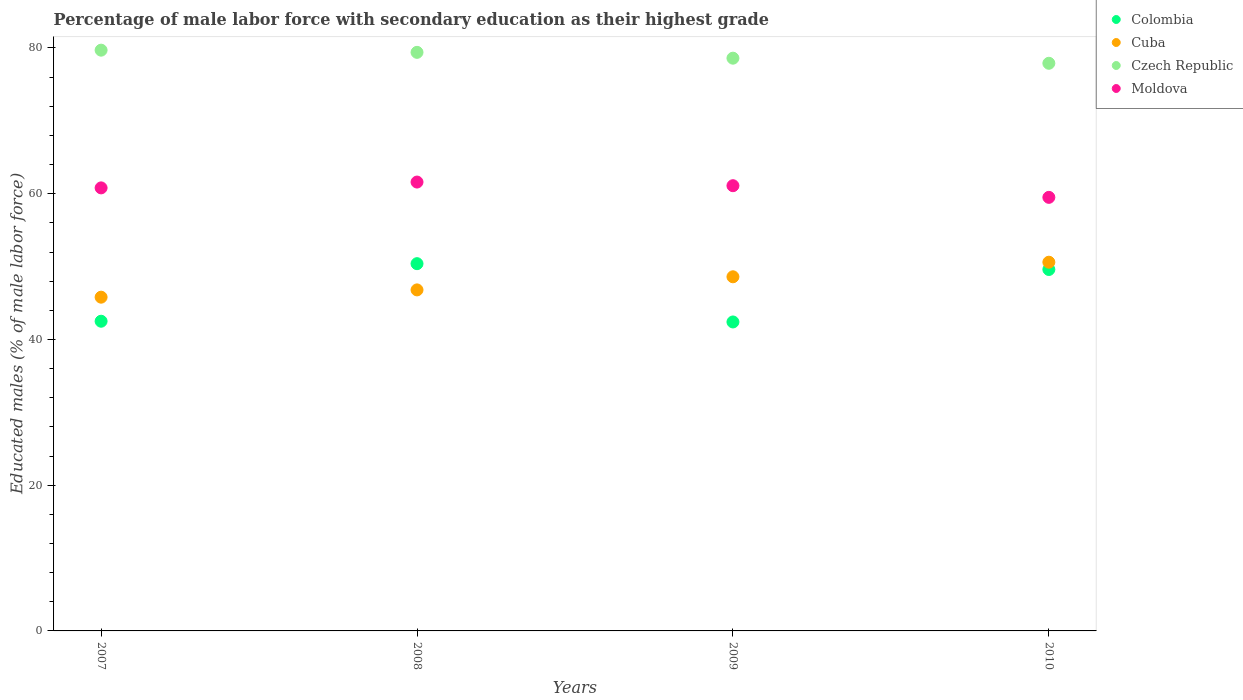How many different coloured dotlines are there?
Offer a very short reply. 4. What is the percentage of male labor force with secondary education in Moldova in 2008?
Keep it short and to the point. 61.6. Across all years, what is the maximum percentage of male labor force with secondary education in Czech Republic?
Your answer should be very brief. 79.7. Across all years, what is the minimum percentage of male labor force with secondary education in Moldova?
Give a very brief answer. 59.5. In which year was the percentage of male labor force with secondary education in Colombia maximum?
Provide a succinct answer. 2008. What is the total percentage of male labor force with secondary education in Colombia in the graph?
Provide a short and direct response. 184.9. What is the difference between the percentage of male labor force with secondary education in Colombia in 2007 and that in 2010?
Offer a very short reply. -7.1. What is the difference between the percentage of male labor force with secondary education in Colombia in 2008 and the percentage of male labor force with secondary education in Moldova in 2009?
Give a very brief answer. -10.7. What is the average percentage of male labor force with secondary education in Czech Republic per year?
Give a very brief answer. 78.9. In the year 2007, what is the difference between the percentage of male labor force with secondary education in Colombia and percentage of male labor force with secondary education in Moldova?
Ensure brevity in your answer.  -18.3. What is the ratio of the percentage of male labor force with secondary education in Moldova in 2007 to that in 2010?
Give a very brief answer. 1.02. Is the difference between the percentage of male labor force with secondary education in Colombia in 2007 and 2010 greater than the difference between the percentage of male labor force with secondary education in Moldova in 2007 and 2010?
Make the answer very short. No. What is the difference between the highest and the second highest percentage of male labor force with secondary education in Colombia?
Offer a terse response. 0.8. What is the difference between the highest and the lowest percentage of male labor force with secondary education in Czech Republic?
Offer a very short reply. 1.8. Is the sum of the percentage of male labor force with secondary education in Colombia in 2008 and 2010 greater than the maximum percentage of male labor force with secondary education in Moldova across all years?
Your answer should be compact. Yes. Is it the case that in every year, the sum of the percentage of male labor force with secondary education in Moldova and percentage of male labor force with secondary education in Cuba  is greater than the sum of percentage of male labor force with secondary education in Colombia and percentage of male labor force with secondary education in Czech Republic?
Your answer should be very brief. No. Is the percentage of male labor force with secondary education in Cuba strictly greater than the percentage of male labor force with secondary education in Czech Republic over the years?
Your response must be concise. No. How many dotlines are there?
Offer a terse response. 4. How many years are there in the graph?
Give a very brief answer. 4. What is the difference between two consecutive major ticks on the Y-axis?
Keep it short and to the point. 20. Does the graph contain grids?
Offer a terse response. No. How are the legend labels stacked?
Offer a very short reply. Vertical. What is the title of the graph?
Ensure brevity in your answer.  Percentage of male labor force with secondary education as their highest grade. Does "Cyprus" appear as one of the legend labels in the graph?
Provide a succinct answer. No. What is the label or title of the X-axis?
Make the answer very short. Years. What is the label or title of the Y-axis?
Ensure brevity in your answer.  Educated males (% of male labor force). What is the Educated males (% of male labor force) of Colombia in 2007?
Give a very brief answer. 42.5. What is the Educated males (% of male labor force) in Cuba in 2007?
Offer a terse response. 45.8. What is the Educated males (% of male labor force) of Czech Republic in 2007?
Ensure brevity in your answer.  79.7. What is the Educated males (% of male labor force) in Moldova in 2007?
Your response must be concise. 60.8. What is the Educated males (% of male labor force) in Colombia in 2008?
Offer a very short reply. 50.4. What is the Educated males (% of male labor force) in Cuba in 2008?
Your answer should be very brief. 46.8. What is the Educated males (% of male labor force) of Czech Republic in 2008?
Your answer should be compact. 79.4. What is the Educated males (% of male labor force) in Moldova in 2008?
Ensure brevity in your answer.  61.6. What is the Educated males (% of male labor force) in Colombia in 2009?
Provide a succinct answer. 42.4. What is the Educated males (% of male labor force) in Cuba in 2009?
Your answer should be very brief. 48.6. What is the Educated males (% of male labor force) of Czech Republic in 2009?
Offer a terse response. 78.6. What is the Educated males (% of male labor force) of Moldova in 2009?
Ensure brevity in your answer.  61.1. What is the Educated males (% of male labor force) in Colombia in 2010?
Your answer should be very brief. 49.6. What is the Educated males (% of male labor force) in Cuba in 2010?
Keep it short and to the point. 50.6. What is the Educated males (% of male labor force) in Czech Republic in 2010?
Offer a terse response. 77.9. What is the Educated males (% of male labor force) in Moldova in 2010?
Your answer should be compact. 59.5. Across all years, what is the maximum Educated males (% of male labor force) in Colombia?
Your response must be concise. 50.4. Across all years, what is the maximum Educated males (% of male labor force) in Cuba?
Offer a terse response. 50.6. Across all years, what is the maximum Educated males (% of male labor force) of Czech Republic?
Give a very brief answer. 79.7. Across all years, what is the maximum Educated males (% of male labor force) in Moldova?
Give a very brief answer. 61.6. Across all years, what is the minimum Educated males (% of male labor force) in Colombia?
Provide a succinct answer. 42.4. Across all years, what is the minimum Educated males (% of male labor force) in Cuba?
Offer a very short reply. 45.8. Across all years, what is the minimum Educated males (% of male labor force) of Czech Republic?
Ensure brevity in your answer.  77.9. Across all years, what is the minimum Educated males (% of male labor force) in Moldova?
Keep it short and to the point. 59.5. What is the total Educated males (% of male labor force) in Colombia in the graph?
Give a very brief answer. 184.9. What is the total Educated males (% of male labor force) in Cuba in the graph?
Ensure brevity in your answer.  191.8. What is the total Educated males (% of male labor force) of Czech Republic in the graph?
Provide a succinct answer. 315.6. What is the total Educated males (% of male labor force) of Moldova in the graph?
Provide a short and direct response. 243. What is the difference between the Educated males (% of male labor force) of Colombia in 2007 and that in 2008?
Your answer should be compact. -7.9. What is the difference between the Educated males (% of male labor force) of Cuba in 2007 and that in 2008?
Your response must be concise. -1. What is the difference between the Educated males (% of male labor force) in Moldova in 2007 and that in 2008?
Keep it short and to the point. -0.8. What is the difference between the Educated males (% of male labor force) of Colombia in 2007 and that in 2009?
Your answer should be compact. 0.1. What is the difference between the Educated males (% of male labor force) in Cuba in 2007 and that in 2009?
Keep it short and to the point. -2.8. What is the difference between the Educated males (% of male labor force) of Czech Republic in 2007 and that in 2009?
Give a very brief answer. 1.1. What is the difference between the Educated males (% of male labor force) in Czech Republic in 2007 and that in 2010?
Your answer should be compact. 1.8. What is the difference between the Educated males (% of male labor force) of Czech Republic in 2008 and that in 2009?
Offer a very short reply. 0.8. What is the difference between the Educated males (% of male labor force) of Moldova in 2008 and that in 2010?
Your response must be concise. 2.1. What is the difference between the Educated males (% of male labor force) of Colombia in 2009 and that in 2010?
Your response must be concise. -7.2. What is the difference between the Educated males (% of male labor force) in Cuba in 2009 and that in 2010?
Keep it short and to the point. -2. What is the difference between the Educated males (% of male labor force) in Moldova in 2009 and that in 2010?
Give a very brief answer. 1.6. What is the difference between the Educated males (% of male labor force) of Colombia in 2007 and the Educated males (% of male labor force) of Czech Republic in 2008?
Ensure brevity in your answer.  -36.9. What is the difference between the Educated males (% of male labor force) of Colombia in 2007 and the Educated males (% of male labor force) of Moldova in 2008?
Keep it short and to the point. -19.1. What is the difference between the Educated males (% of male labor force) in Cuba in 2007 and the Educated males (% of male labor force) in Czech Republic in 2008?
Ensure brevity in your answer.  -33.6. What is the difference between the Educated males (% of male labor force) of Cuba in 2007 and the Educated males (% of male labor force) of Moldova in 2008?
Your answer should be very brief. -15.8. What is the difference between the Educated males (% of male labor force) in Colombia in 2007 and the Educated males (% of male labor force) in Cuba in 2009?
Your answer should be compact. -6.1. What is the difference between the Educated males (% of male labor force) of Colombia in 2007 and the Educated males (% of male labor force) of Czech Republic in 2009?
Make the answer very short. -36.1. What is the difference between the Educated males (% of male labor force) in Colombia in 2007 and the Educated males (% of male labor force) in Moldova in 2009?
Make the answer very short. -18.6. What is the difference between the Educated males (% of male labor force) of Cuba in 2007 and the Educated males (% of male labor force) of Czech Republic in 2009?
Give a very brief answer. -32.8. What is the difference between the Educated males (% of male labor force) of Cuba in 2007 and the Educated males (% of male labor force) of Moldova in 2009?
Give a very brief answer. -15.3. What is the difference between the Educated males (% of male labor force) of Czech Republic in 2007 and the Educated males (% of male labor force) of Moldova in 2009?
Offer a terse response. 18.6. What is the difference between the Educated males (% of male labor force) in Colombia in 2007 and the Educated males (% of male labor force) in Cuba in 2010?
Give a very brief answer. -8.1. What is the difference between the Educated males (% of male labor force) of Colombia in 2007 and the Educated males (% of male labor force) of Czech Republic in 2010?
Keep it short and to the point. -35.4. What is the difference between the Educated males (% of male labor force) of Cuba in 2007 and the Educated males (% of male labor force) of Czech Republic in 2010?
Offer a very short reply. -32.1. What is the difference between the Educated males (% of male labor force) in Cuba in 2007 and the Educated males (% of male labor force) in Moldova in 2010?
Ensure brevity in your answer.  -13.7. What is the difference between the Educated males (% of male labor force) in Czech Republic in 2007 and the Educated males (% of male labor force) in Moldova in 2010?
Keep it short and to the point. 20.2. What is the difference between the Educated males (% of male labor force) of Colombia in 2008 and the Educated males (% of male labor force) of Czech Republic in 2009?
Provide a succinct answer. -28.2. What is the difference between the Educated males (% of male labor force) in Colombia in 2008 and the Educated males (% of male labor force) in Moldova in 2009?
Ensure brevity in your answer.  -10.7. What is the difference between the Educated males (% of male labor force) in Cuba in 2008 and the Educated males (% of male labor force) in Czech Republic in 2009?
Make the answer very short. -31.8. What is the difference between the Educated males (% of male labor force) in Cuba in 2008 and the Educated males (% of male labor force) in Moldova in 2009?
Ensure brevity in your answer.  -14.3. What is the difference between the Educated males (% of male labor force) in Colombia in 2008 and the Educated males (% of male labor force) in Czech Republic in 2010?
Ensure brevity in your answer.  -27.5. What is the difference between the Educated males (% of male labor force) in Cuba in 2008 and the Educated males (% of male labor force) in Czech Republic in 2010?
Ensure brevity in your answer.  -31.1. What is the difference between the Educated males (% of male labor force) in Cuba in 2008 and the Educated males (% of male labor force) in Moldova in 2010?
Provide a short and direct response. -12.7. What is the difference between the Educated males (% of male labor force) of Czech Republic in 2008 and the Educated males (% of male labor force) of Moldova in 2010?
Offer a very short reply. 19.9. What is the difference between the Educated males (% of male labor force) in Colombia in 2009 and the Educated males (% of male labor force) in Cuba in 2010?
Offer a terse response. -8.2. What is the difference between the Educated males (% of male labor force) in Colombia in 2009 and the Educated males (% of male labor force) in Czech Republic in 2010?
Keep it short and to the point. -35.5. What is the difference between the Educated males (% of male labor force) of Colombia in 2009 and the Educated males (% of male labor force) of Moldova in 2010?
Ensure brevity in your answer.  -17.1. What is the difference between the Educated males (% of male labor force) of Cuba in 2009 and the Educated males (% of male labor force) of Czech Republic in 2010?
Your answer should be very brief. -29.3. What is the difference between the Educated males (% of male labor force) in Cuba in 2009 and the Educated males (% of male labor force) in Moldova in 2010?
Provide a short and direct response. -10.9. What is the difference between the Educated males (% of male labor force) of Czech Republic in 2009 and the Educated males (% of male labor force) of Moldova in 2010?
Ensure brevity in your answer.  19.1. What is the average Educated males (% of male labor force) of Colombia per year?
Give a very brief answer. 46.23. What is the average Educated males (% of male labor force) of Cuba per year?
Provide a short and direct response. 47.95. What is the average Educated males (% of male labor force) of Czech Republic per year?
Your answer should be compact. 78.9. What is the average Educated males (% of male labor force) in Moldova per year?
Give a very brief answer. 60.75. In the year 2007, what is the difference between the Educated males (% of male labor force) in Colombia and Educated males (% of male labor force) in Czech Republic?
Your response must be concise. -37.2. In the year 2007, what is the difference between the Educated males (% of male labor force) of Colombia and Educated males (% of male labor force) of Moldova?
Provide a succinct answer. -18.3. In the year 2007, what is the difference between the Educated males (% of male labor force) in Cuba and Educated males (% of male labor force) in Czech Republic?
Ensure brevity in your answer.  -33.9. In the year 2007, what is the difference between the Educated males (% of male labor force) of Cuba and Educated males (% of male labor force) of Moldova?
Offer a very short reply. -15. In the year 2007, what is the difference between the Educated males (% of male labor force) of Czech Republic and Educated males (% of male labor force) of Moldova?
Your answer should be very brief. 18.9. In the year 2008, what is the difference between the Educated males (% of male labor force) in Colombia and Educated males (% of male labor force) in Czech Republic?
Offer a very short reply. -29. In the year 2008, what is the difference between the Educated males (% of male labor force) of Colombia and Educated males (% of male labor force) of Moldova?
Give a very brief answer. -11.2. In the year 2008, what is the difference between the Educated males (% of male labor force) in Cuba and Educated males (% of male labor force) in Czech Republic?
Provide a short and direct response. -32.6. In the year 2008, what is the difference between the Educated males (% of male labor force) in Cuba and Educated males (% of male labor force) in Moldova?
Make the answer very short. -14.8. In the year 2008, what is the difference between the Educated males (% of male labor force) of Czech Republic and Educated males (% of male labor force) of Moldova?
Provide a succinct answer. 17.8. In the year 2009, what is the difference between the Educated males (% of male labor force) of Colombia and Educated males (% of male labor force) of Czech Republic?
Ensure brevity in your answer.  -36.2. In the year 2009, what is the difference between the Educated males (% of male labor force) of Colombia and Educated males (% of male labor force) of Moldova?
Ensure brevity in your answer.  -18.7. In the year 2009, what is the difference between the Educated males (% of male labor force) in Czech Republic and Educated males (% of male labor force) in Moldova?
Keep it short and to the point. 17.5. In the year 2010, what is the difference between the Educated males (% of male labor force) in Colombia and Educated males (% of male labor force) in Czech Republic?
Offer a very short reply. -28.3. In the year 2010, what is the difference between the Educated males (% of male labor force) of Cuba and Educated males (% of male labor force) of Czech Republic?
Make the answer very short. -27.3. What is the ratio of the Educated males (% of male labor force) of Colombia in 2007 to that in 2008?
Offer a very short reply. 0.84. What is the ratio of the Educated males (% of male labor force) in Cuba in 2007 to that in 2008?
Give a very brief answer. 0.98. What is the ratio of the Educated males (% of male labor force) of Czech Republic in 2007 to that in 2008?
Give a very brief answer. 1. What is the ratio of the Educated males (% of male labor force) in Moldova in 2007 to that in 2008?
Offer a very short reply. 0.99. What is the ratio of the Educated males (% of male labor force) of Cuba in 2007 to that in 2009?
Your response must be concise. 0.94. What is the ratio of the Educated males (% of male labor force) in Czech Republic in 2007 to that in 2009?
Your response must be concise. 1.01. What is the ratio of the Educated males (% of male labor force) of Moldova in 2007 to that in 2009?
Offer a very short reply. 1. What is the ratio of the Educated males (% of male labor force) of Colombia in 2007 to that in 2010?
Keep it short and to the point. 0.86. What is the ratio of the Educated males (% of male labor force) of Cuba in 2007 to that in 2010?
Your answer should be compact. 0.91. What is the ratio of the Educated males (% of male labor force) in Czech Republic in 2007 to that in 2010?
Provide a short and direct response. 1.02. What is the ratio of the Educated males (% of male labor force) of Moldova in 2007 to that in 2010?
Your answer should be very brief. 1.02. What is the ratio of the Educated males (% of male labor force) of Colombia in 2008 to that in 2009?
Make the answer very short. 1.19. What is the ratio of the Educated males (% of male labor force) in Cuba in 2008 to that in 2009?
Your answer should be compact. 0.96. What is the ratio of the Educated males (% of male labor force) in Czech Republic in 2008 to that in 2009?
Give a very brief answer. 1.01. What is the ratio of the Educated males (% of male labor force) in Moldova in 2008 to that in 2009?
Your response must be concise. 1.01. What is the ratio of the Educated males (% of male labor force) in Colombia in 2008 to that in 2010?
Offer a terse response. 1.02. What is the ratio of the Educated males (% of male labor force) of Cuba in 2008 to that in 2010?
Ensure brevity in your answer.  0.92. What is the ratio of the Educated males (% of male labor force) in Czech Republic in 2008 to that in 2010?
Your answer should be very brief. 1.02. What is the ratio of the Educated males (% of male labor force) in Moldova in 2008 to that in 2010?
Provide a succinct answer. 1.04. What is the ratio of the Educated males (% of male labor force) of Colombia in 2009 to that in 2010?
Provide a short and direct response. 0.85. What is the ratio of the Educated males (% of male labor force) of Cuba in 2009 to that in 2010?
Offer a terse response. 0.96. What is the ratio of the Educated males (% of male labor force) in Czech Republic in 2009 to that in 2010?
Your response must be concise. 1.01. What is the ratio of the Educated males (% of male labor force) in Moldova in 2009 to that in 2010?
Provide a succinct answer. 1.03. What is the difference between the highest and the second highest Educated males (% of male labor force) in Colombia?
Your answer should be very brief. 0.8. What is the difference between the highest and the second highest Educated males (% of male labor force) of Cuba?
Provide a succinct answer. 2. What is the difference between the highest and the second highest Educated males (% of male labor force) of Czech Republic?
Provide a short and direct response. 0.3. What is the difference between the highest and the second highest Educated males (% of male labor force) of Moldova?
Make the answer very short. 0.5. What is the difference between the highest and the lowest Educated males (% of male labor force) of Cuba?
Your answer should be compact. 4.8. What is the difference between the highest and the lowest Educated males (% of male labor force) in Czech Republic?
Your answer should be compact. 1.8. What is the difference between the highest and the lowest Educated males (% of male labor force) in Moldova?
Offer a terse response. 2.1. 